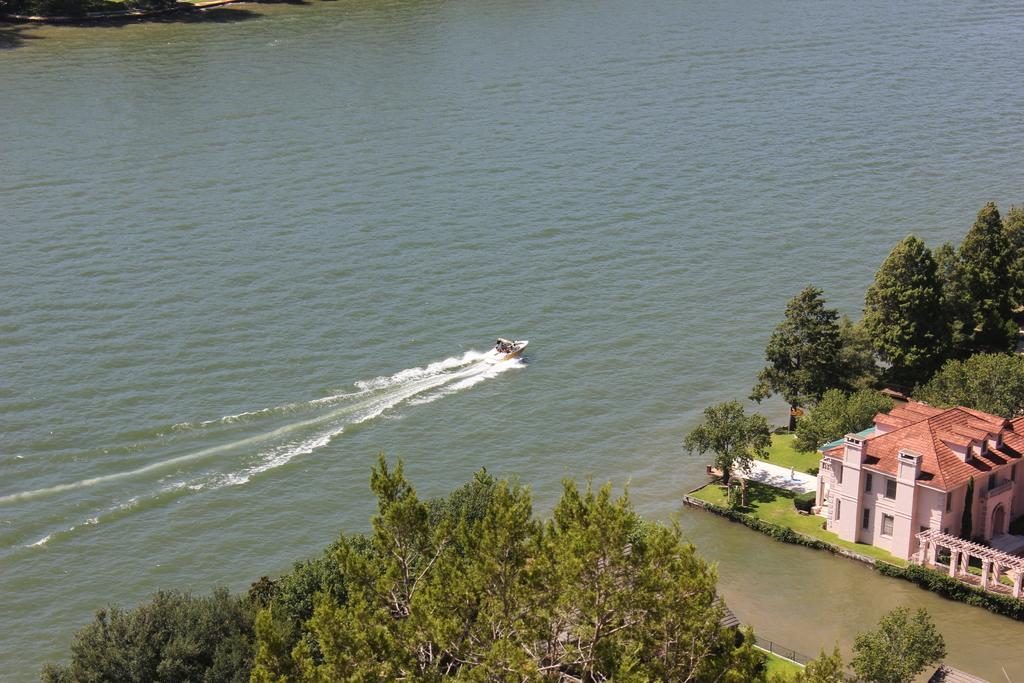Can you describe this image briefly? This is an aerial view of an image where I can see trees, houses, grass and a boat is floating on the water. 